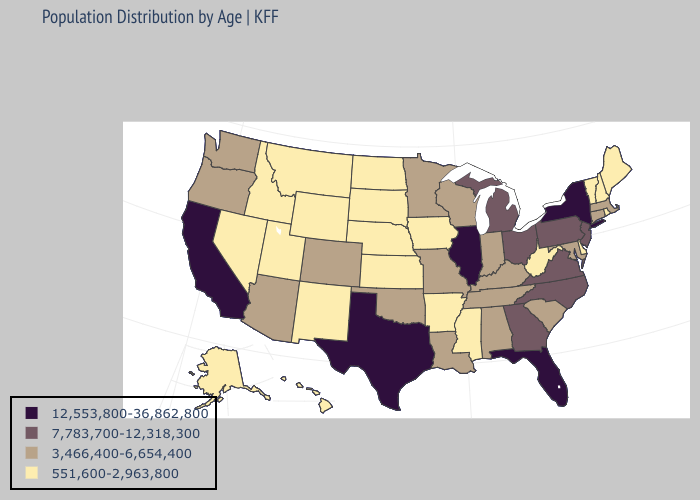Name the states that have a value in the range 12,553,800-36,862,800?
Give a very brief answer. California, Florida, Illinois, New York, Texas. What is the value of New Mexico?
Quick response, please. 551,600-2,963,800. Does Illinois have the highest value in the USA?
Be succinct. Yes. What is the highest value in states that border Delaware?
Give a very brief answer. 7,783,700-12,318,300. What is the lowest value in the USA?
Short answer required. 551,600-2,963,800. Does Minnesota have a higher value than Washington?
Write a very short answer. No. Does Washington have a higher value than Alaska?
Concise answer only. Yes. Which states have the lowest value in the USA?
Give a very brief answer. Alaska, Arkansas, Delaware, Hawaii, Idaho, Iowa, Kansas, Maine, Mississippi, Montana, Nebraska, Nevada, New Hampshire, New Mexico, North Dakota, Rhode Island, South Dakota, Utah, Vermont, West Virginia, Wyoming. What is the value of Texas?
Short answer required. 12,553,800-36,862,800. Does Washington have the lowest value in the West?
Concise answer only. No. How many symbols are there in the legend?
Write a very short answer. 4. Which states have the lowest value in the USA?
Quick response, please. Alaska, Arkansas, Delaware, Hawaii, Idaho, Iowa, Kansas, Maine, Mississippi, Montana, Nebraska, Nevada, New Hampshire, New Mexico, North Dakota, Rhode Island, South Dakota, Utah, Vermont, West Virginia, Wyoming. What is the highest value in the Northeast ?
Short answer required. 12,553,800-36,862,800. Which states have the lowest value in the MidWest?
Write a very short answer. Iowa, Kansas, Nebraska, North Dakota, South Dakota. 